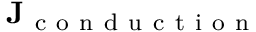<formula> <loc_0><loc_0><loc_500><loc_500>J _ { c o n d u c t i o n }</formula> 